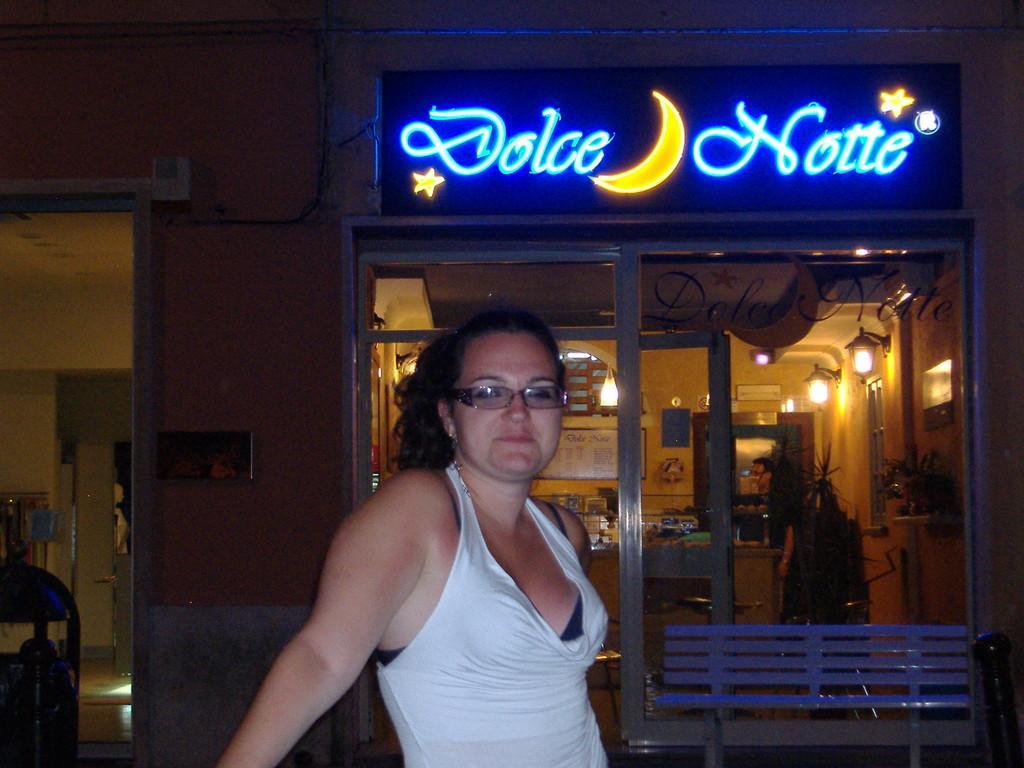How would you summarize this image in a sentence or two? In this picture, there is a woman in the center wearing white clothes and spectacles. Behind her, there is a stall with some text. 